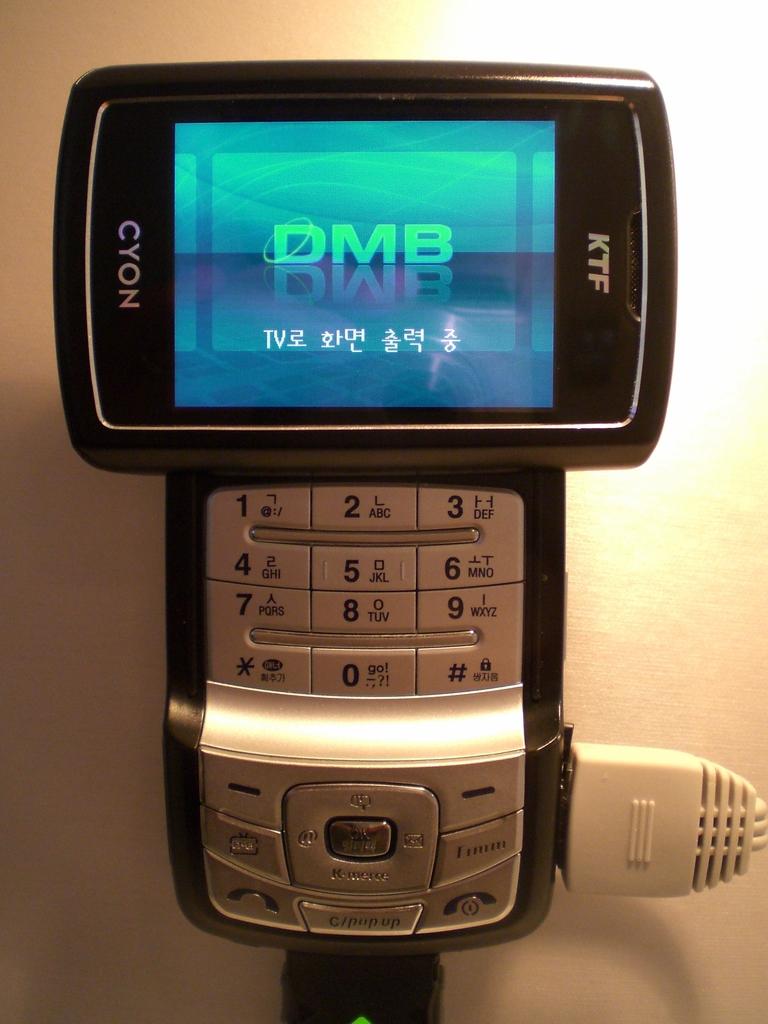What brand of phone is this?
Offer a terse response. Cyon. What is displayed on the screen?
Keep it short and to the point. Dmb. 